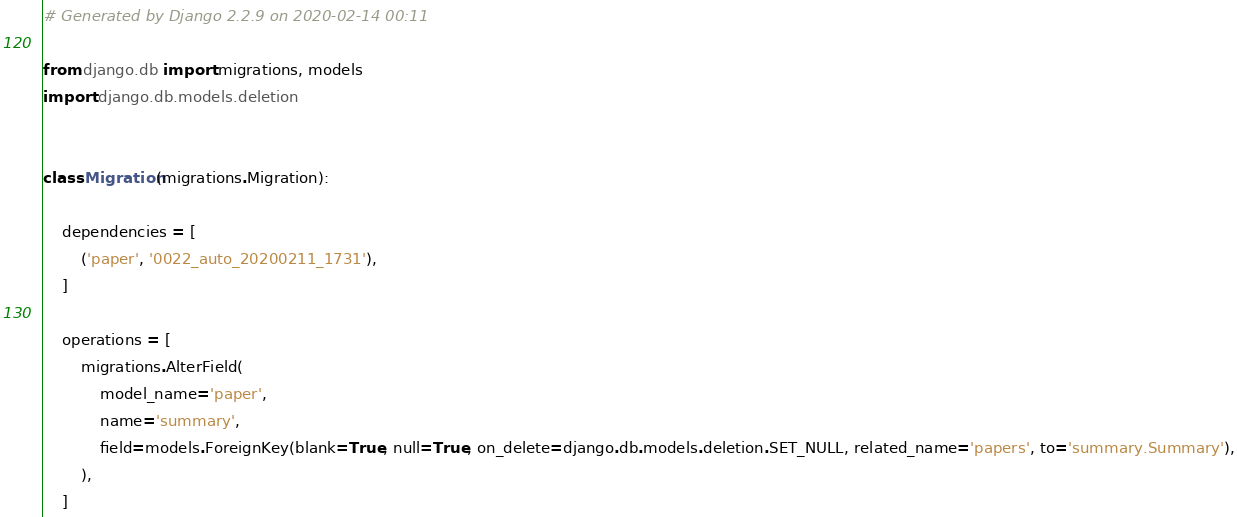<code> <loc_0><loc_0><loc_500><loc_500><_Python_># Generated by Django 2.2.9 on 2020-02-14 00:11

from django.db import migrations, models
import django.db.models.deletion


class Migration(migrations.Migration):

    dependencies = [
        ('paper', '0022_auto_20200211_1731'),
    ]

    operations = [
        migrations.AlterField(
            model_name='paper',
            name='summary',
            field=models.ForeignKey(blank=True, null=True, on_delete=django.db.models.deletion.SET_NULL, related_name='papers', to='summary.Summary'),
        ),
    ]
</code> 